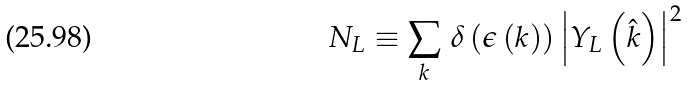<formula> <loc_0><loc_0><loc_500><loc_500>N _ { L } \equiv \sum _ { k } \, \delta \left ( \epsilon \left ( { k } \right ) \right ) \left | Y _ { L } \left ( { \hat { k } } \right ) \right | ^ { 2 }</formula> 